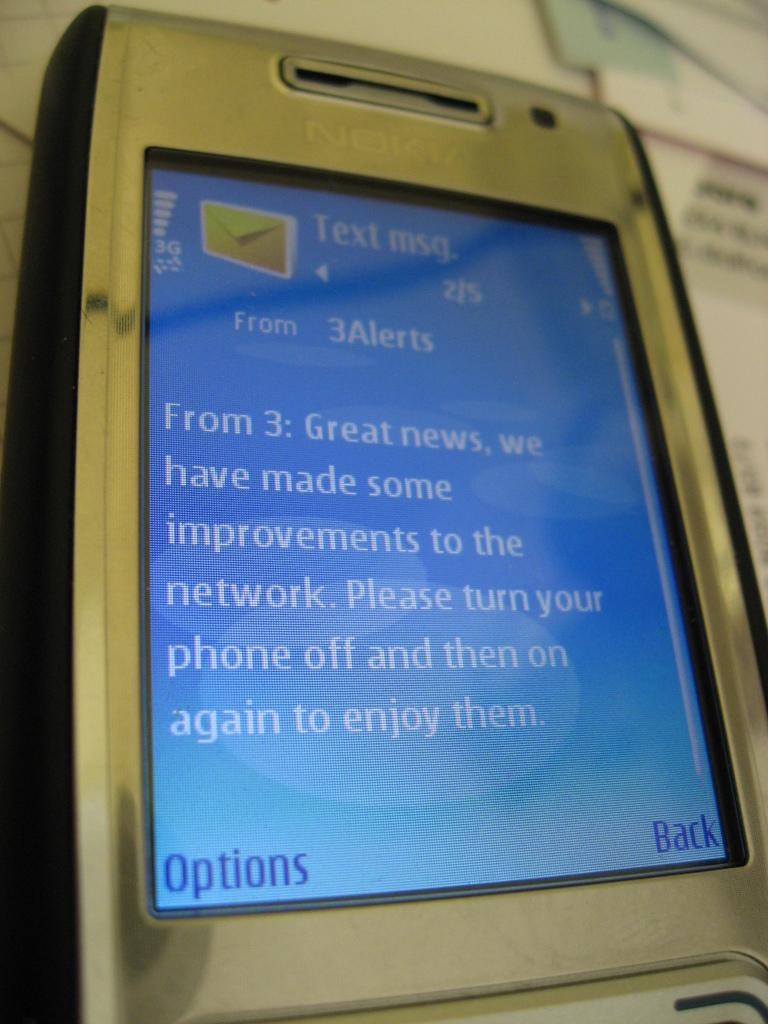<image>
Write a terse but informative summary of the picture. An old Nokia phone displaying a text message that starts with "great news". 